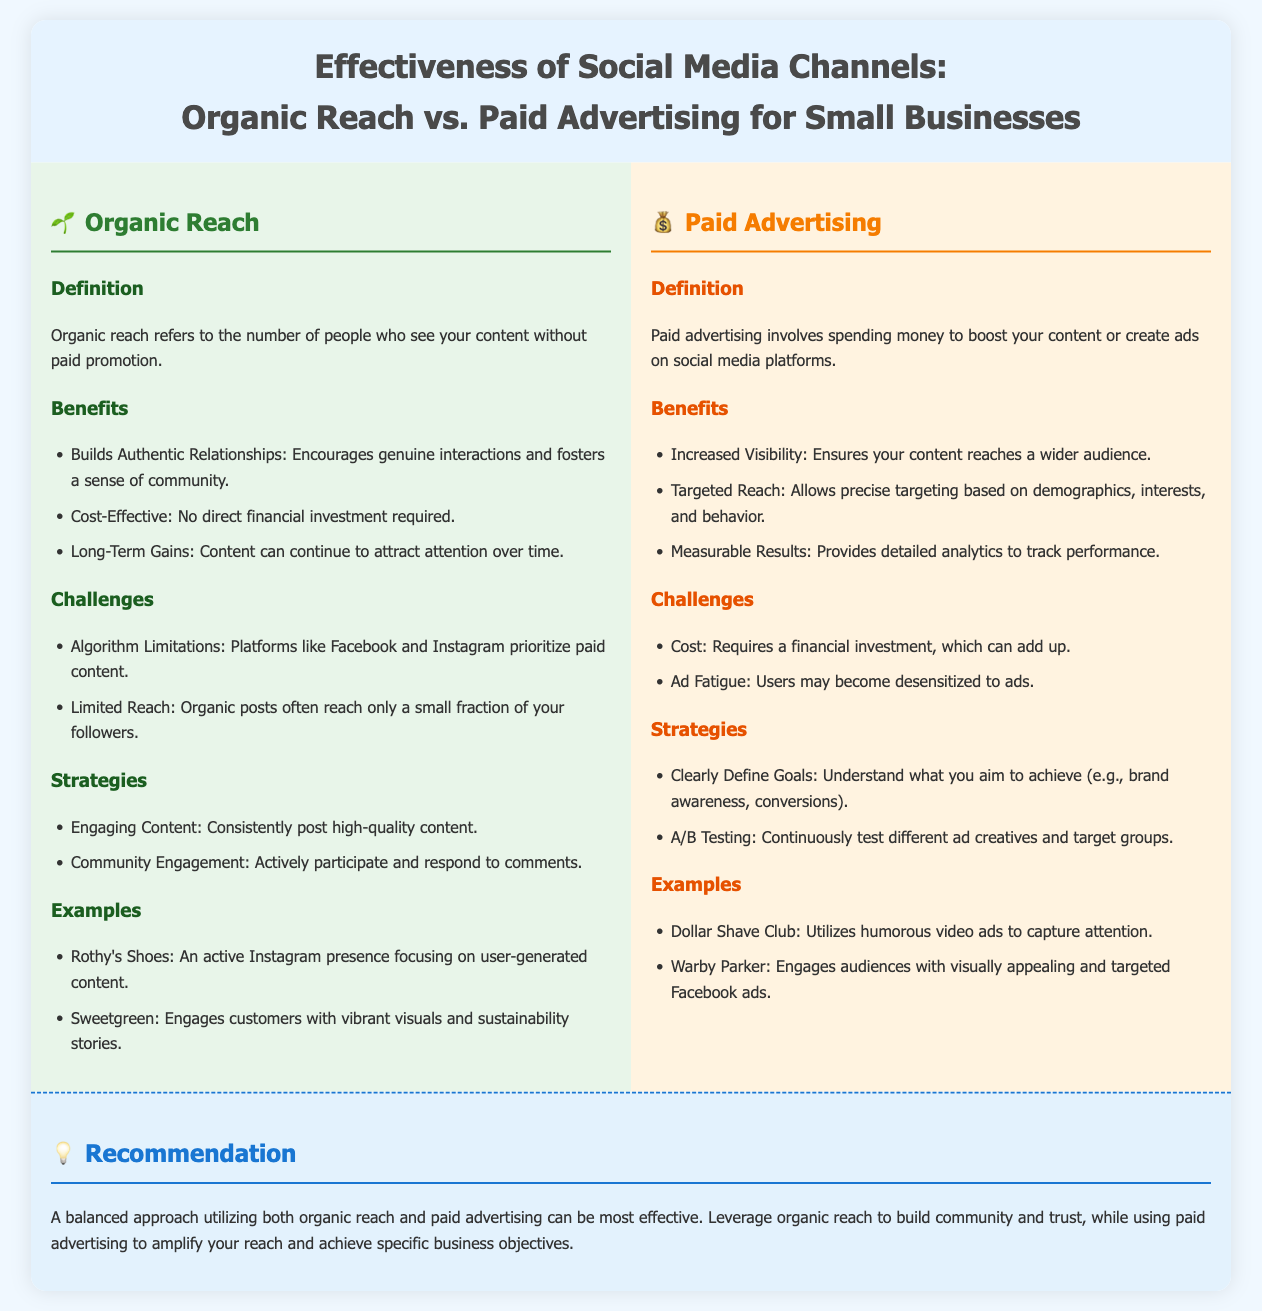What is organic reach? Organic reach refers to the number of people who see your content without paid promotion.
Answer: The number of people who see your content without paid promotion What are two benefits of organic reach? The benefits listed in the document include building authentic relationships and being cost-effective.
Answer: Builds Authentic Relationships, Cost-Effective What is a major challenge of paid advertising? The challenges outlined include cost and ad fatigue.
Answer: Cost Which company is mentioned as an example of effective organic reach? Rothy's Shoes is provided as an example of a brand effectively using organic reach through user-generated content.
Answer: Rothy's Shoes What is one strategy for improving organic reach? The strategies mentioned include consistently posting high-quality content.
Answer: Consistently post high-quality content What type of results does paid advertising provide? Paid advertising provides measurable results through detailed analytics.
Answer: Measurable Results Which brand is highlighted for its humorous video ads in paid advertising? Dollar Shave Club is cited as utilizing humorous video ads to capture attention.
Answer: Dollar Shave Club What is the recommendation for small businesses regarding social media channels? The document recommends a balanced approach utilizing both organic reach and paid advertising.
Answer: A balanced approach utilizing both organic reach and paid advertising What color represents organic reach in the infographic? The background color for organic reach is a shade of green, which represents the organic aspect.
Answer: Green 